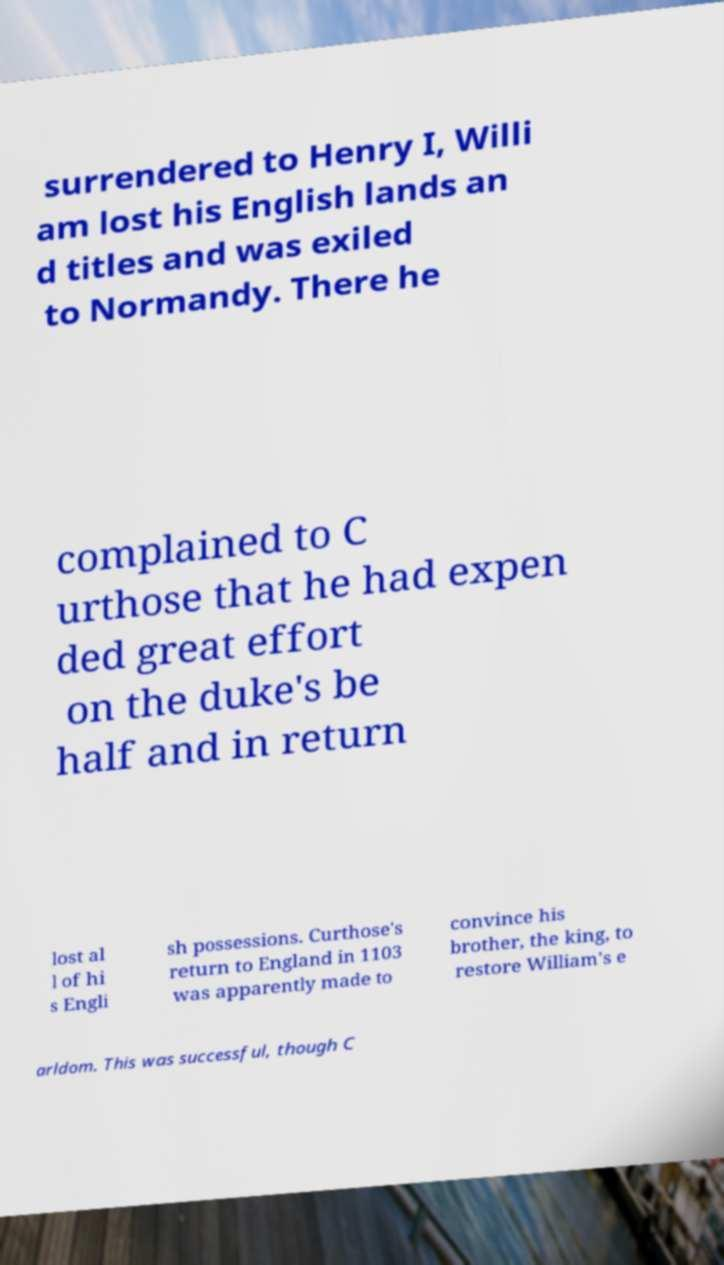Please read and relay the text visible in this image. What does it say? surrendered to Henry I, Willi am lost his English lands an d titles and was exiled to Normandy. There he complained to C urthose that he had expen ded great effort on the duke's be half and in return lost al l of hi s Engli sh possessions. Curthose's return to England in 1103 was apparently made to convince his brother, the king, to restore William's e arldom. This was successful, though C 